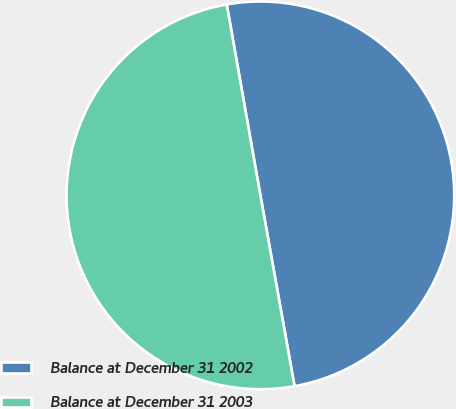Convert chart. <chart><loc_0><loc_0><loc_500><loc_500><pie_chart><fcel>Balance at December 31 2002<fcel>Balance at December 31 2003<nl><fcel>49.96%<fcel>50.04%<nl></chart> 